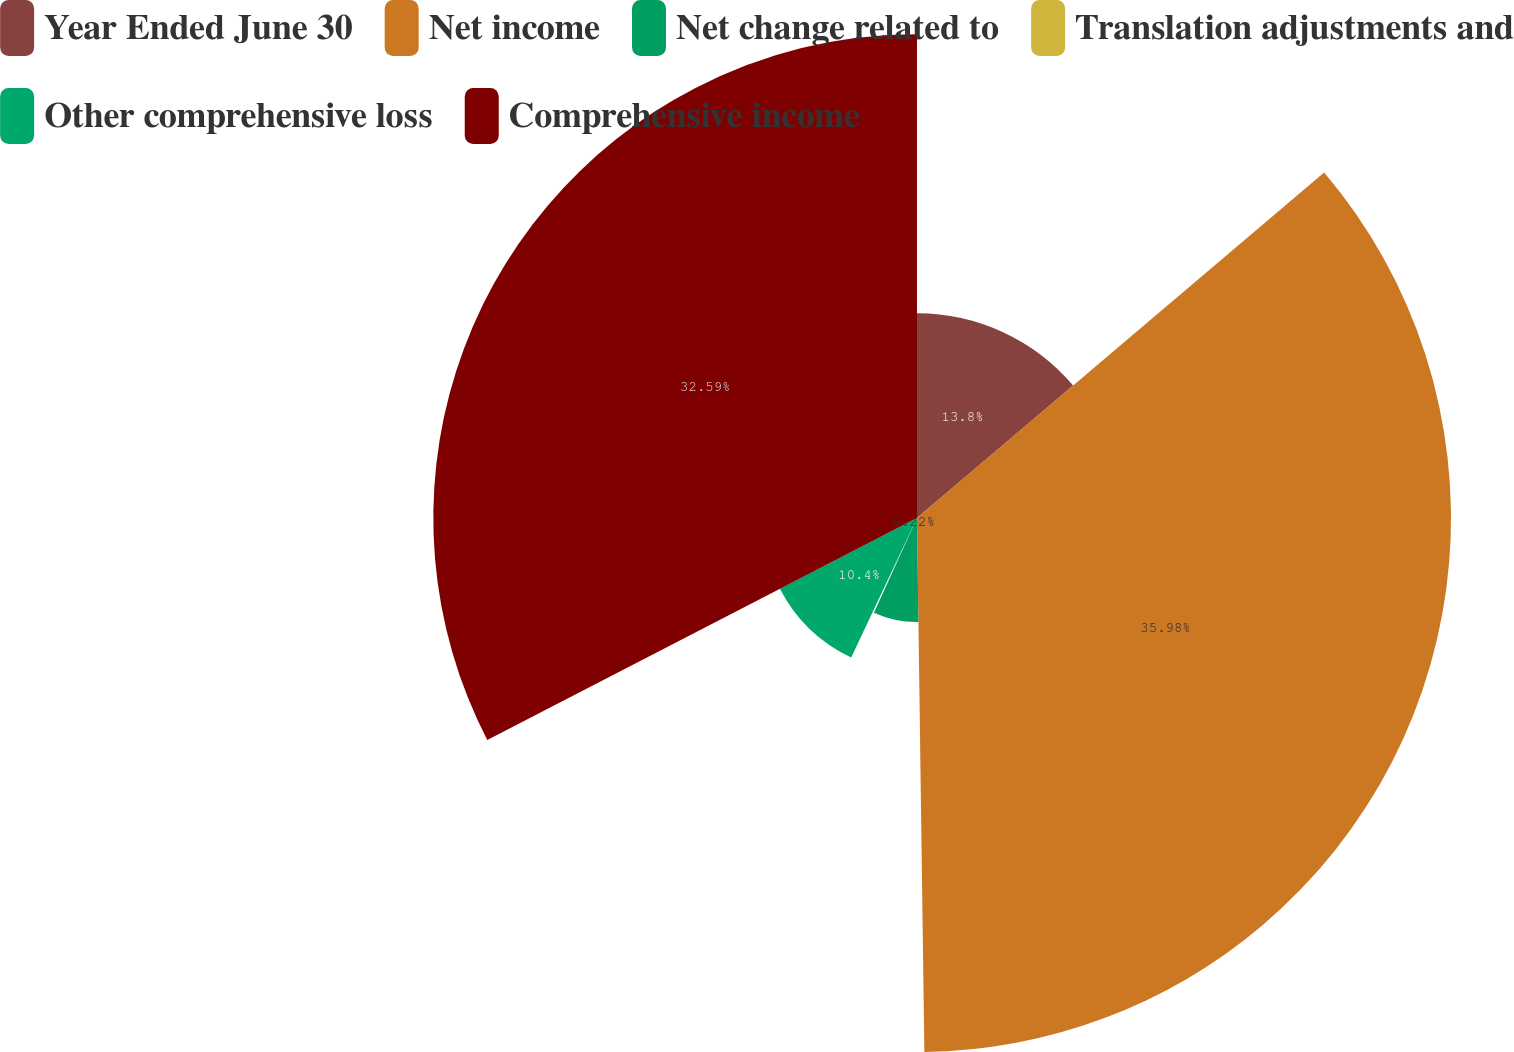Convert chart to OTSL. <chart><loc_0><loc_0><loc_500><loc_500><pie_chart><fcel>Year Ended June 30<fcel>Net income<fcel>Net change related to<fcel>Translation adjustments and<fcel>Other comprehensive loss<fcel>Comprehensive income<nl><fcel>13.8%<fcel>35.98%<fcel>7.01%<fcel>0.22%<fcel>10.4%<fcel>32.59%<nl></chart> 